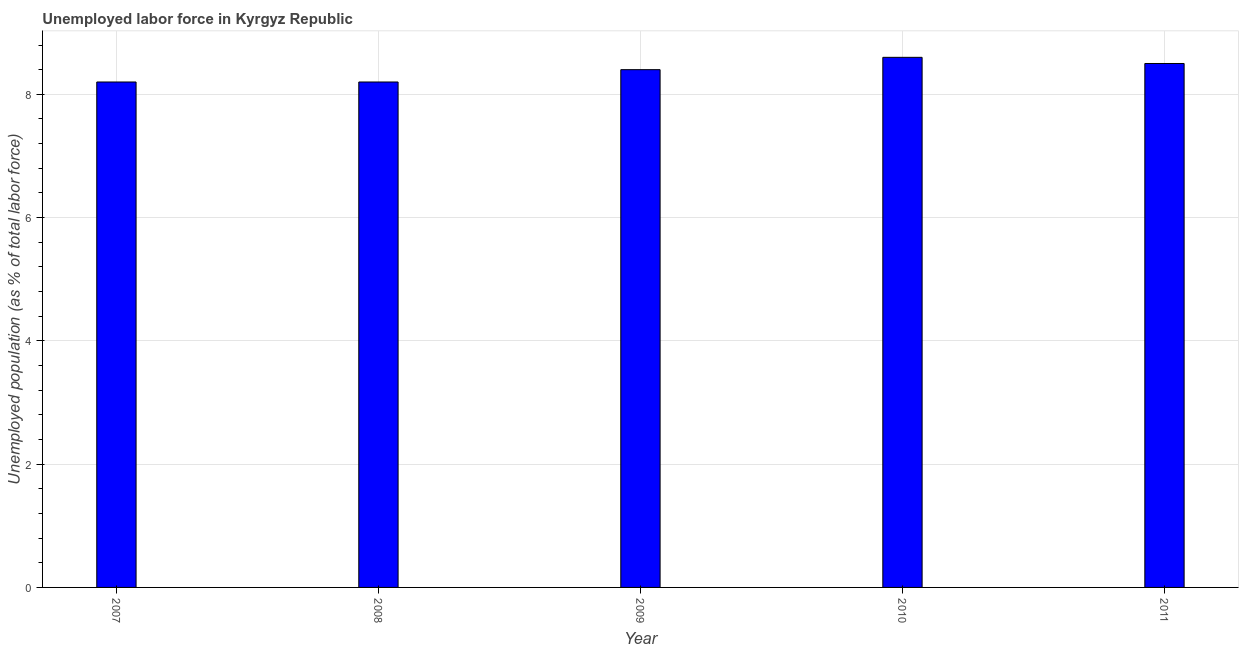Does the graph contain grids?
Make the answer very short. Yes. What is the title of the graph?
Provide a succinct answer. Unemployed labor force in Kyrgyz Republic. What is the label or title of the Y-axis?
Offer a terse response. Unemployed population (as % of total labor force). What is the total unemployed population in 2010?
Provide a succinct answer. 8.6. Across all years, what is the maximum total unemployed population?
Provide a short and direct response. 8.6. Across all years, what is the minimum total unemployed population?
Offer a very short reply. 8.2. What is the sum of the total unemployed population?
Your answer should be very brief. 41.9. What is the average total unemployed population per year?
Provide a succinct answer. 8.38. What is the median total unemployed population?
Provide a succinct answer. 8.4. Is the difference between the total unemployed population in 2009 and 2010 greater than the difference between any two years?
Your response must be concise. No. How many bars are there?
Make the answer very short. 5. What is the difference between two consecutive major ticks on the Y-axis?
Your response must be concise. 2. What is the Unemployed population (as % of total labor force) of 2007?
Provide a succinct answer. 8.2. What is the Unemployed population (as % of total labor force) in 2008?
Provide a succinct answer. 8.2. What is the Unemployed population (as % of total labor force) of 2009?
Provide a succinct answer. 8.4. What is the Unemployed population (as % of total labor force) in 2010?
Keep it short and to the point. 8.6. What is the difference between the Unemployed population (as % of total labor force) in 2007 and 2010?
Offer a very short reply. -0.4. What is the difference between the Unemployed population (as % of total labor force) in 2008 and 2009?
Give a very brief answer. -0.2. What is the difference between the Unemployed population (as % of total labor force) in 2008 and 2010?
Your answer should be compact. -0.4. What is the difference between the Unemployed population (as % of total labor force) in 2008 and 2011?
Your answer should be very brief. -0.3. What is the difference between the Unemployed population (as % of total labor force) in 2009 and 2010?
Make the answer very short. -0.2. What is the ratio of the Unemployed population (as % of total labor force) in 2007 to that in 2008?
Ensure brevity in your answer.  1. What is the ratio of the Unemployed population (as % of total labor force) in 2007 to that in 2010?
Offer a very short reply. 0.95. What is the ratio of the Unemployed population (as % of total labor force) in 2008 to that in 2009?
Your response must be concise. 0.98. What is the ratio of the Unemployed population (as % of total labor force) in 2008 to that in 2010?
Your response must be concise. 0.95. What is the ratio of the Unemployed population (as % of total labor force) in 2008 to that in 2011?
Provide a short and direct response. 0.96. What is the ratio of the Unemployed population (as % of total labor force) in 2009 to that in 2010?
Offer a terse response. 0.98. 